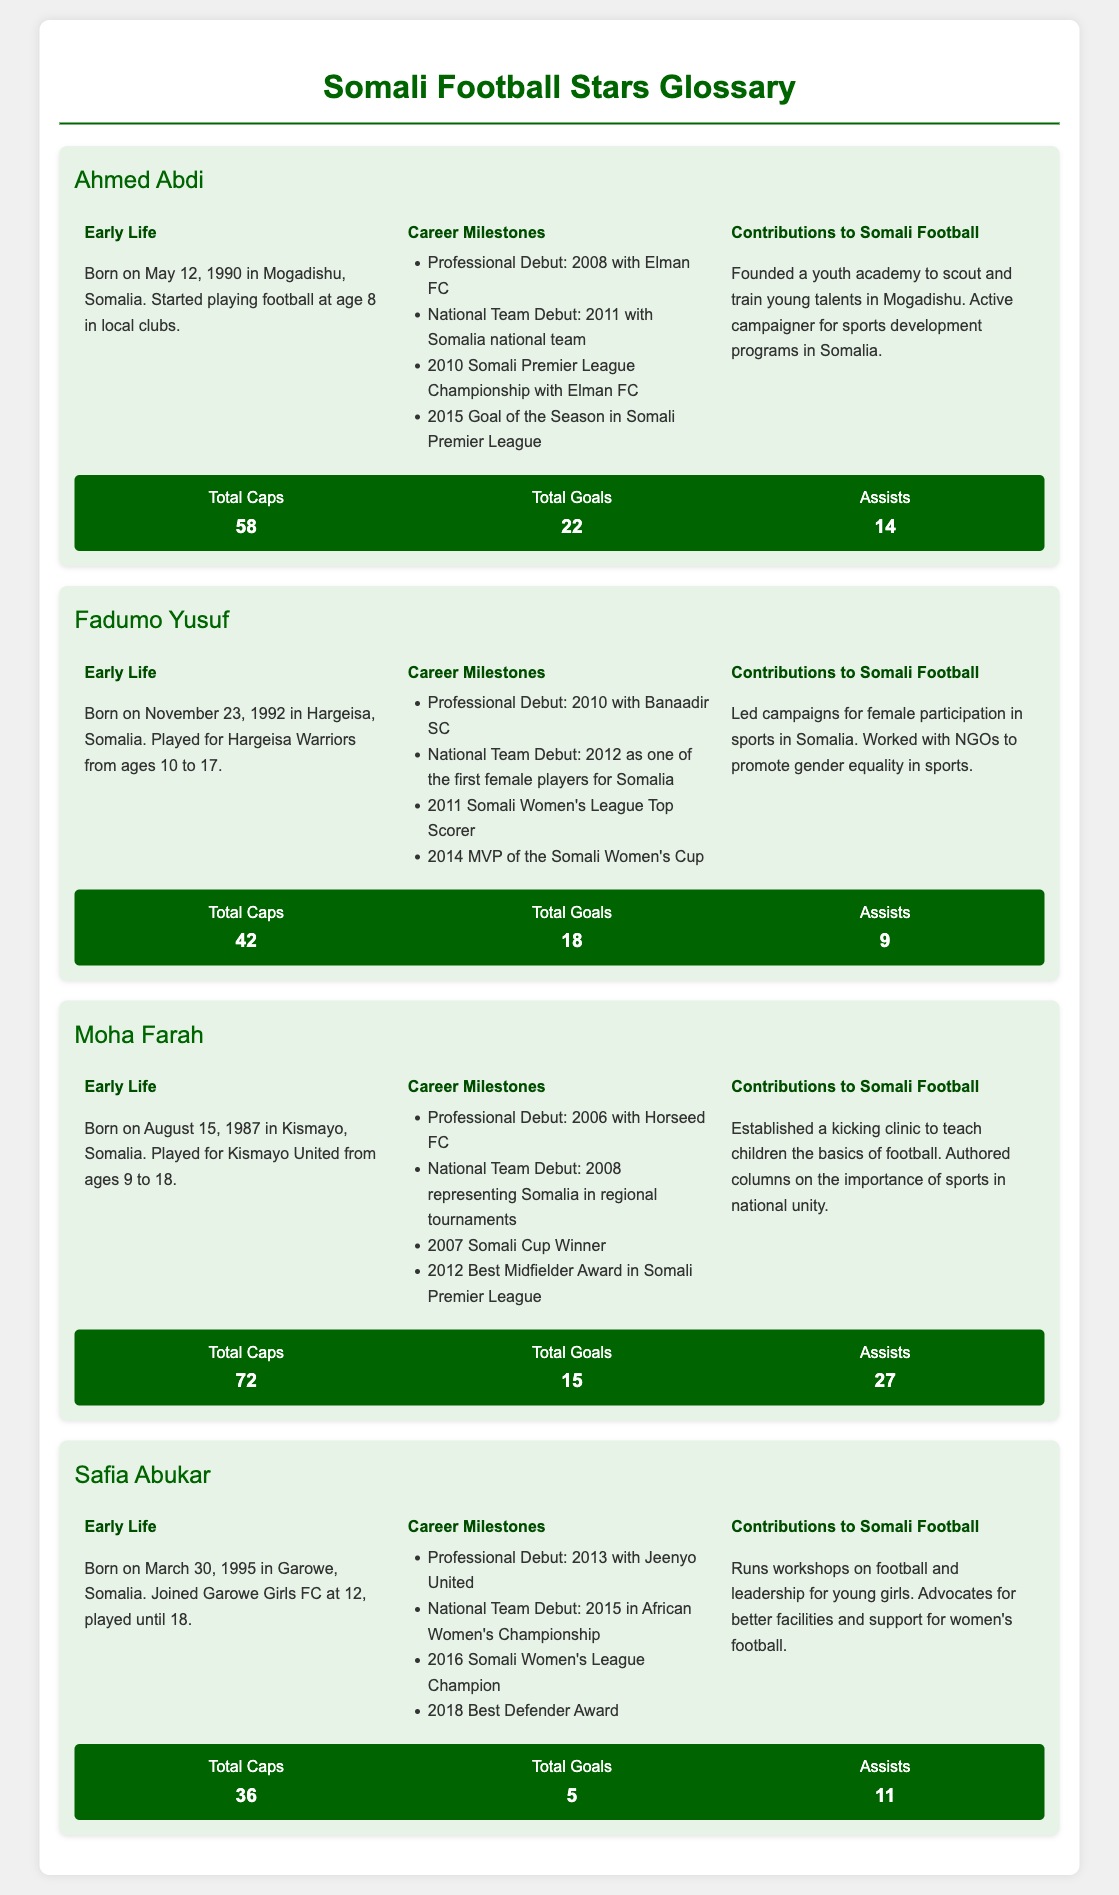What is Ahmed Abdi's total goals? The total goals scored by Ahmed Abdi is mentioned clearly in his player profile under stats.
Answer: 22 What year did Fadumo Yusuf make her national team debut? Fadumo Yusuf's national team debut year is provided in her career milestones.
Answer: 2012 How many assists did Moha Farah achieve? The number of assists by Moha Farah is listed in his player statistics.
Answer: 27 What significant event occurred for Safia Abukar in 2018? Safia Abukar's achievements for that year are highlighted in her career milestones.
Answer: Best Defender Award How old was Ahmed Abdi when he started playing football? They provided the age at which Ahmed Abdi began playing football in his early life section.
Answer: 8 